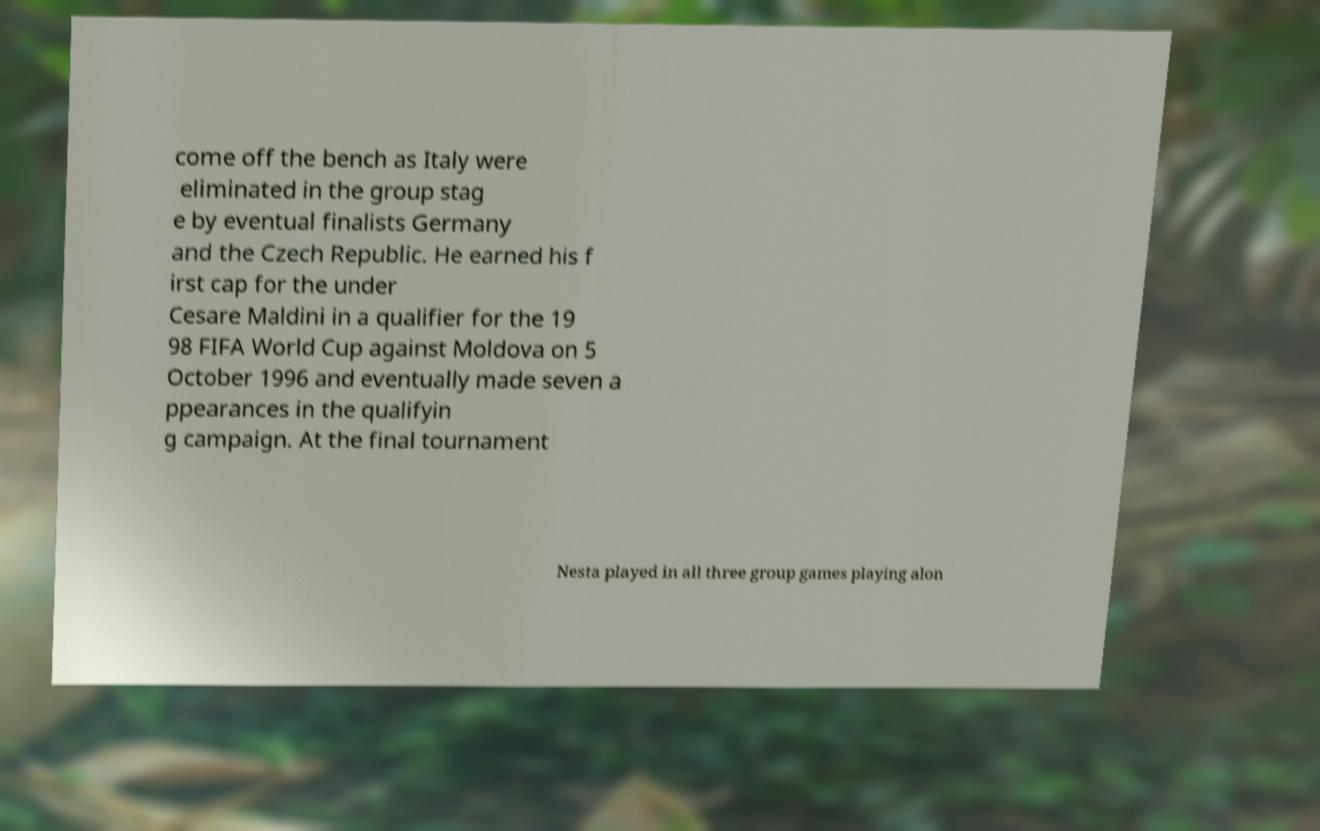There's text embedded in this image that I need extracted. Can you transcribe it verbatim? come off the bench as Italy were eliminated in the group stag e by eventual finalists Germany and the Czech Republic. He earned his f irst cap for the under Cesare Maldini in a qualifier for the 19 98 FIFA World Cup against Moldova on 5 October 1996 and eventually made seven a ppearances in the qualifyin g campaign. At the final tournament Nesta played in all three group games playing alon 